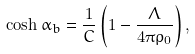Convert formula to latex. <formula><loc_0><loc_0><loc_500><loc_500>\cosh \alpha _ { b } = \frac { 1 } { C } \left ( 1 - \frac { \Lambda } { 4 \pi \rho _ { 0 } } \right ) ,</formula> 